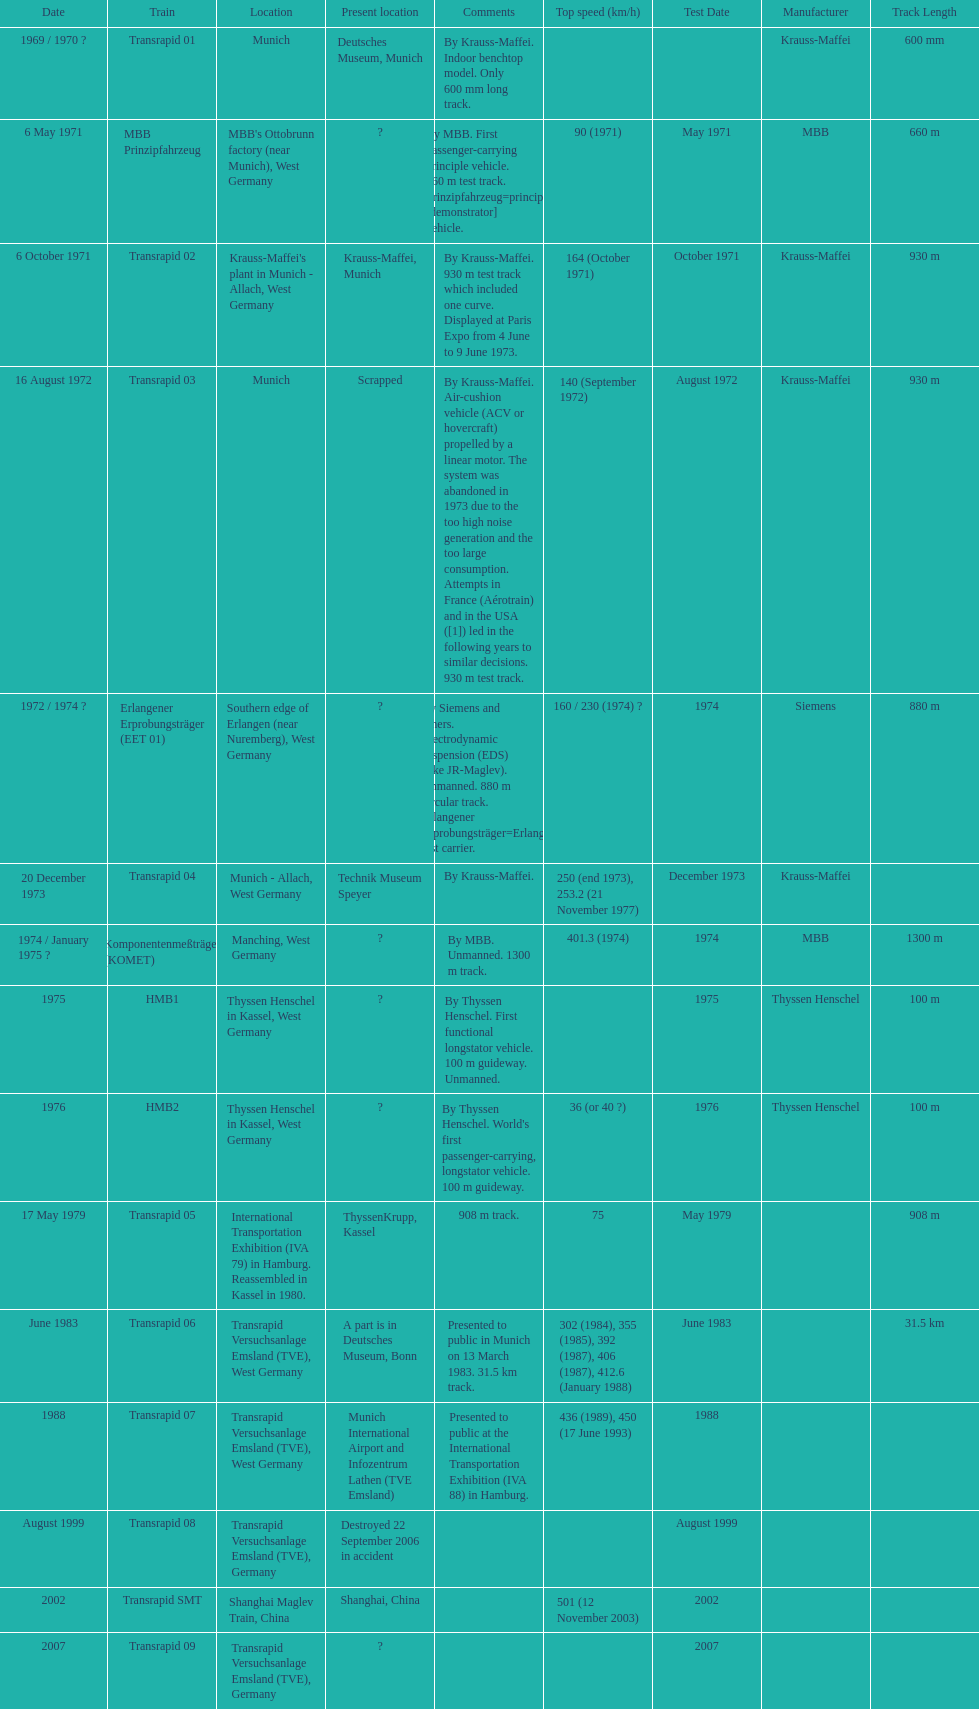High noise generation and too large consumption led to what train being scrapped? Transrapid 03. Could you parse the entire table as a dict? {'header': ['Date', 'Train', 'Location', 'Present location', 'Comments', 'Top speed (km/h)', 'Test Date', 'Manufacturer', 'Track Length'], 'rows': [['1969 / 1970\xa0?', 'Transrapid 01', 'Munich', 'Deutsches Museum, Munich', 'By Krauss-Maffei. Indoor benchtop model. Only 600\xa0mm long track.', '', '', 'Krauss-Maffei', '600 mm'], ['6 May 1971', 'MBB Prinzipfahrzeug', "MBB's Ottobrunn factory (near Munich), West Germany", '?', 'By MBB. First passenger-carrying principle vehicle. 660 m test track. Prinzipfahrzeug=principle [demonstrator] vehicle.', '90 (1971)', 'May 1971', 'MBB', '660 m'], ['6 October 1971', 'Transrapid 02', "Krauss-Maffei's plant in Munich - Allach, West Germany", 'Krauss-Maffei, Munich', 'By Krauss-Maffei. 930 m test track which included one curve. Displayed at Paris Expo from 4 June to 9 June 1973.', '164 (October 1971)', 'October 1971', 'Krauss-Maffei', '930 m'], ['16 August 1972', 'Transrapid 03', 'Munich', 'Scrapped', 'By Krauss-Maffei. Air-cushion vehicle (ACV or hovercraft) propelled by a linear motor. The system was abandoned in 1973 due to the too high noise generation and the too large consumption. Attempts in France (Aérotrain) and in the USA ([1]) led in the following years to similar decisions. 930 m test track.', '140 (September 1972)', 'August 1972', 'Krauss-Maffei', '930 m'], ['1972 / 1974\xa0?', 'Erlangener Erprobungsträger (EET 01)', 'Southern edge of Erlangen (near Nuremberg), West Germany', '?', 'By Siemens and others. Electrodynamic suspension (EDS) (like JR-Maglev). Unmanned. 880 m circular track. Erlangener Erprobungsträger=Erlangen test carrier.', '160 / 230 (1974)\xa0?', '1974', 'Siemens', '880 m'], ['20 December 1973', 'Transrapid 04', 'Munich - Allach, West Germany', 'Technik Museum Speyer', 'By Krauss-Maffei.', '250 (end 1973), 253.2 (21 November 1977)', 'December 1973', 'Krauss-Maffei', ''], ['1974 / January 1975\xa0?', 'Komponentenmeßträger (KOMET)', 'Manching, West Germany', '?', 'By MBB. Unmanned. 1300 m track.', '401.3 (1974)', '1974', 'MBB', '1300 m'], ['1975', 'HMB1', 'Thyssen Henschel in Kassel, West Germany', '?', 'By Thyssen Henschel. First functional longstator vehicle. 100 m guideway. Unmanned.', '', '1975', 'Thyssen Henschel', '100 m'], ['1976', 'HMB2', 'Thyssen Henschel in Kassel, West Germany', '?', "By Thyssen Henschel. World's first passenger-carrying, longstator vehicle. 100 m guideway.", '36 (or 40\xa0?)', '1976', 'Thyssen Henschel', '100 m'], ['17 May 1979', 'Transrapid 05', 'International Transportation Exhibition (IVA 79) in Hamburg. Reassembled in Kassel in 1980.', 'ThyssenKrupp, Kassel', '908 m track.', '75', 'May 1979', '', '908 m'], ['June 1983', 'Transrapid 06', 'Transrapid Versuchsanlage Emsland (TVE), West Germany', 'A part is in Deutsches Museum, Bonn', 'Presented to public in Munich on 13 March 1983. 31.5\xa0km track.', '302 (1984), 355 (1985), 392 (1987), 406 (1987), 412.6 (January 1988)', 'June 1983', '', '31.5 km'], ['1988', 'Transrapid 07', 'Transrapid Versuchsanlage Emsland (TVE), West Germany', 'Munich International Airport and Infozentrum Lathen (TVE Emsland)', 'Presented to public at the International Transportation Exhibition (IVA 88) in Hamburg.', '436 (1989), 450 (17 June 1993)', '1988', '', ''], ['August 1999', 'Transrapid 08', 'Transrapid Versuchsanlage Emsland (TVE), Germany', 'Destroyed 22 September 2006 in accident', '', '', 'August 1999', '', ''], ['2002', 'Transrapid SMT', 'Shanghai Maglev Train, China', 'Shanghai, China', '', '501 (12 November 2003)', '2002', '', ''], ['2007', 'Transrapid 09', 'Transrapid Versuchsanlage Emsland (TVE), Germany', '?', '', '', '2007', '', '']]} 